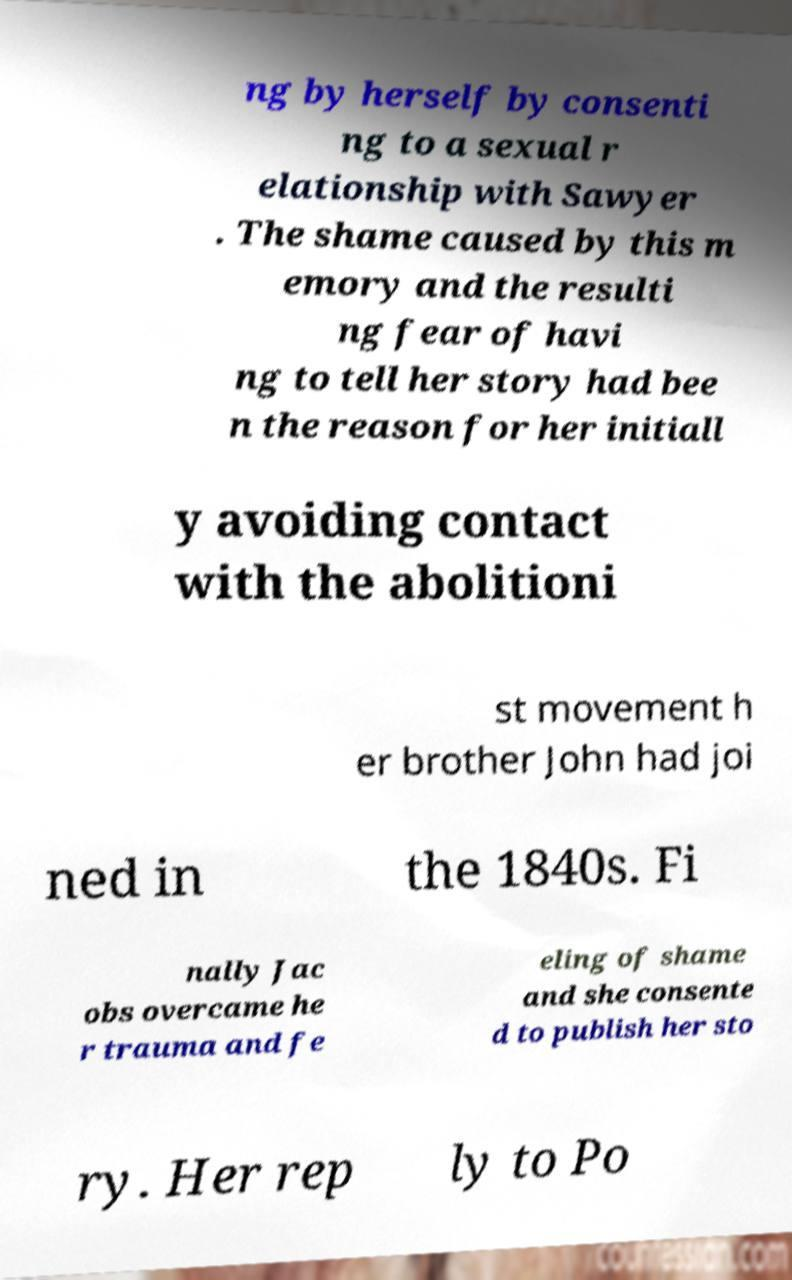Could you assist in decoding the text presented in this image and type it out clearly? ng by herself by consenti ng to a sexual r elationship with Sawyer . The shame caused by this m emory and the resulti ng fear of havi ng to tell her story had bee n the reason for her initiall y avoiding contact with the abolitioni st movement h er brother John had joi ned in the 1840s. Fi nally Jac obs overcame he r trauma and fe eling of shame and she consente d to publish her sto ry. Her rep ly to Po 